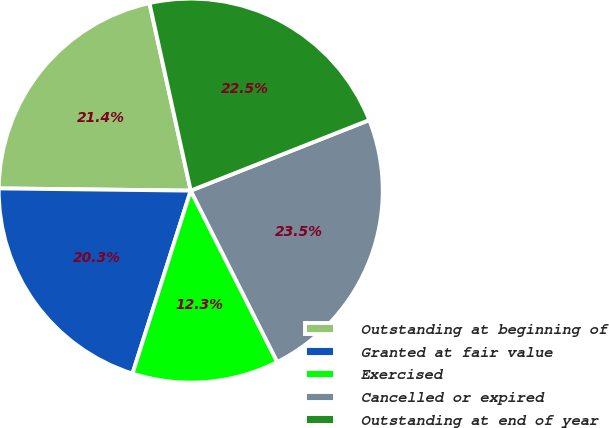<chart> <loc_0><loc_0><loc_500><loc_500><pie_chart><fcel>Outstanding at beginning of<fcel>Granted at fair value<fcel>Exercised<fcel>Cancelled or expired<fcel>Outstanding at end of year<nl><fcel>21.37%<fcel>20.28%<fcel>12.35%<fcel>23.55%<fcel>22.46%<nl></chart> 